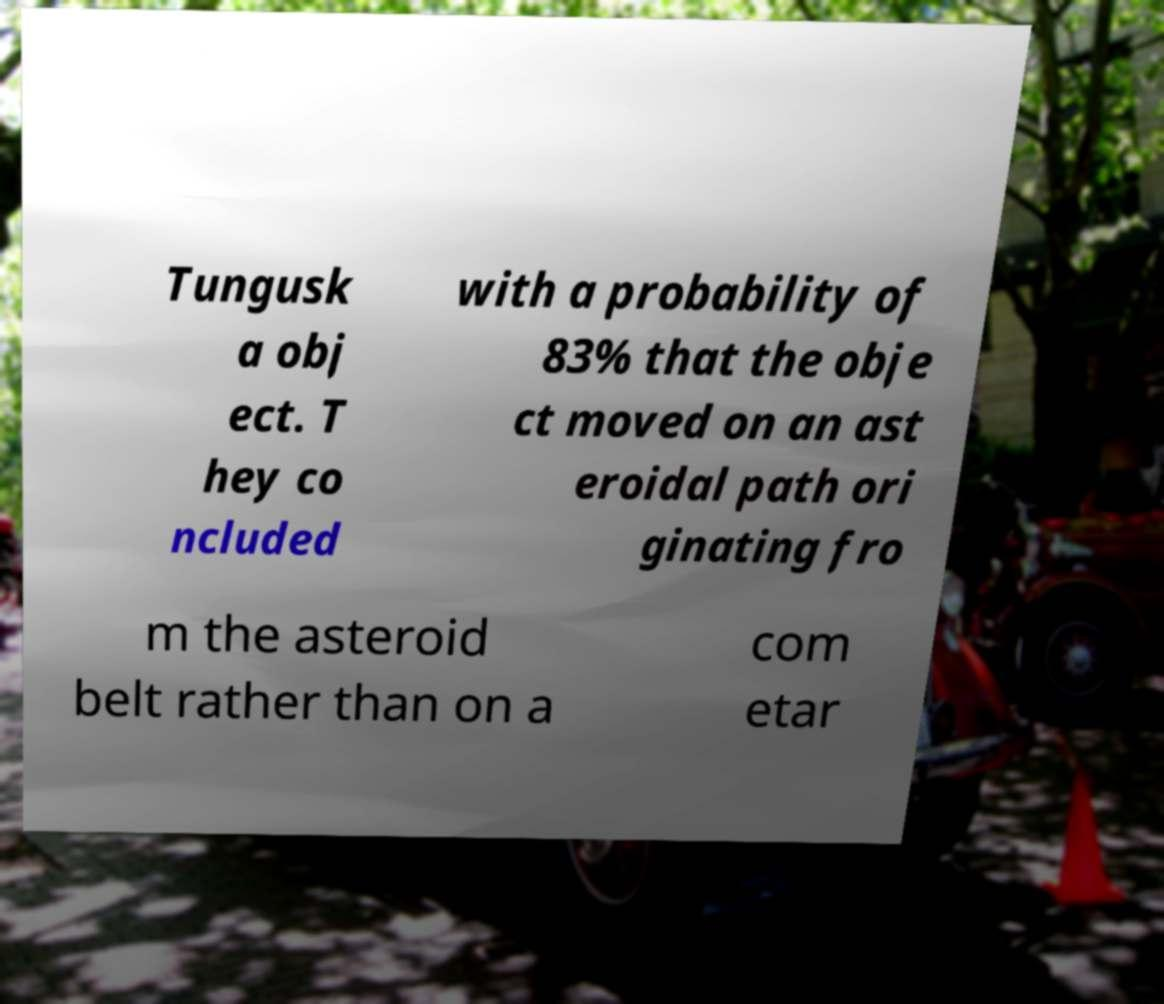For documentation purposes, I need the text within this image transcribed. Could you provide that? Tungusk a obj ect. T hey co ncluded with a probability of 83% that the obje ct moved on an ast eroidal path ori ginating fro m the asteroid belt rather than on a com etar 